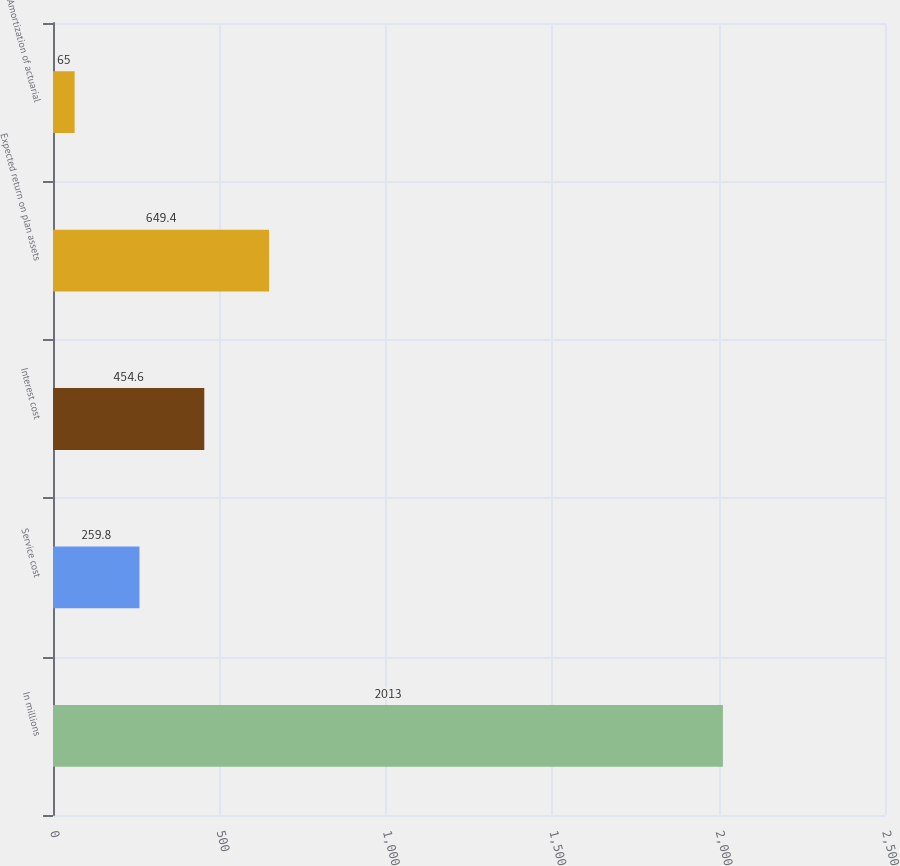<chart> <loc_0><loc_0><loc_500><loc_500><bar_chart><fcel>In millions<fcel>Service cost<fcel>Interest cost<fcel>Expected return on plan assets<fcel>Amortization of actuarial<nl><fcel>2013<fcel>259.8<fcel>454.6<fcel>649.4<fcel>65<nl></chart> 